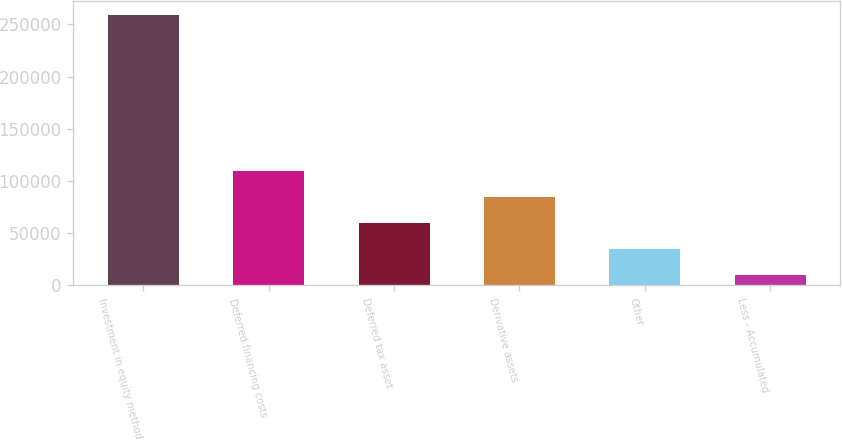<chart> <loc_0><loc_0><loc_500><loc_500><bar_chart><fcel>Investment in equity method<fcel>Deferred financing costs<fcel>Deferred tax asset<fcel>Derivative assets<fcel>Other<fcel>Less - Accumulated<nl><fcel>259181<fcel>109308<fcel>59349.8<fcel>84328.7<fcel>34370.9<fcel>9392<nl></chart> 